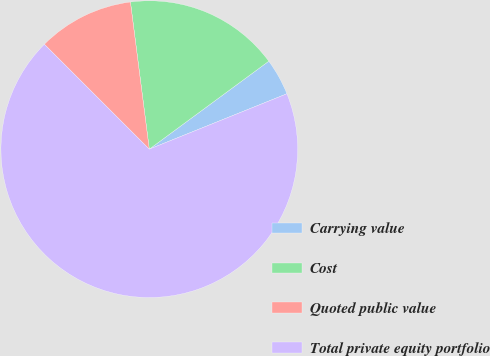<chart> <loc_0><loc_0><loc_500><loc_500><pie_chart><fcel>Carrying value<fcel>Cost<fcel>Quoted public value<fcel>Total private equity portfolio<nl><fcel>4.01%<fcel>16.93%<fcel>10.47%<fcel>68.59%<nl></chart> 